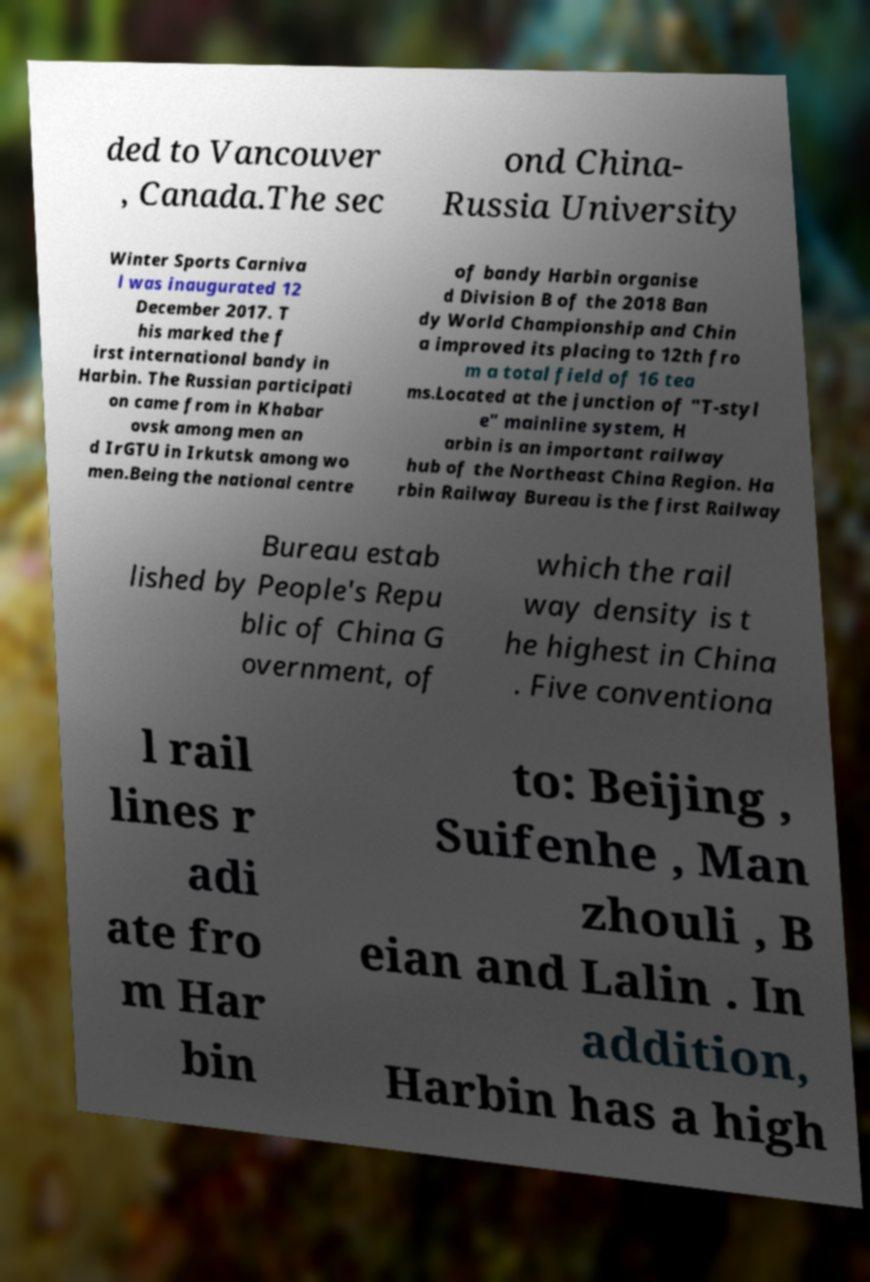Please read and relay the text visible in this image. What does it say? ded to Vancouver , Canada.The sec ond China- Russia University Winter Sports Carniva l was inaugurated 12 December 2017. T his marked the f irst international bandy in Harbin. The Russian participati on came from in Khabar ovsk among men an d IrGTU in Irkutsk among wo men.Being the national centre of bandy Harbin organise d Division B of the 2018 Ban dy World Championship and Chin a improved its placing to 12th fro m a total field of 16 tea ms.Located at the junction of "T-styl e" mainline system, H arbin is an important railway hub of the Northeast China Region. Ha rbin Railway Bureau is the first Railway Bureau estab lished by People's Repu blic of China G overnment, of which the rail way density is t he highest in China . Five conventiona l rail lines r adi ate fro m Har bin to: Beijing , Suifenhe , Man zhouli , B eian and Lalin . In addition, Harbin has a high 